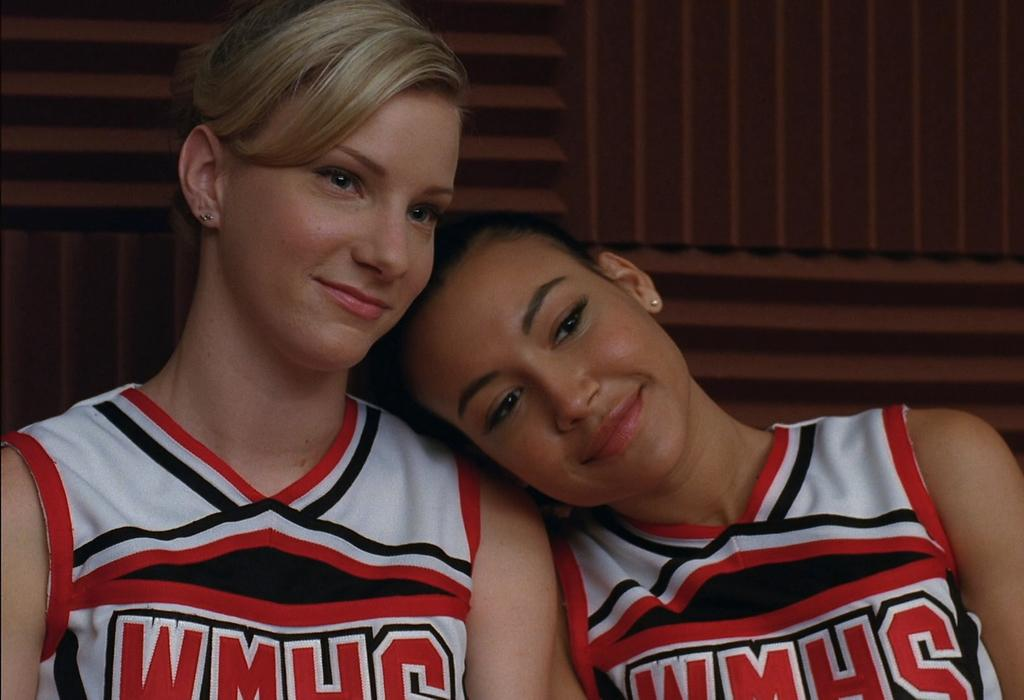Where was the image taken? The image was taken indoors. What can be seen in the background of the image? There is a wall in the background of the image. How many people are present in the image? There are two women in the image. What type of snail can be seen crawling on the wall in the image? There are no snails present in the image; it only features two women indoors. 